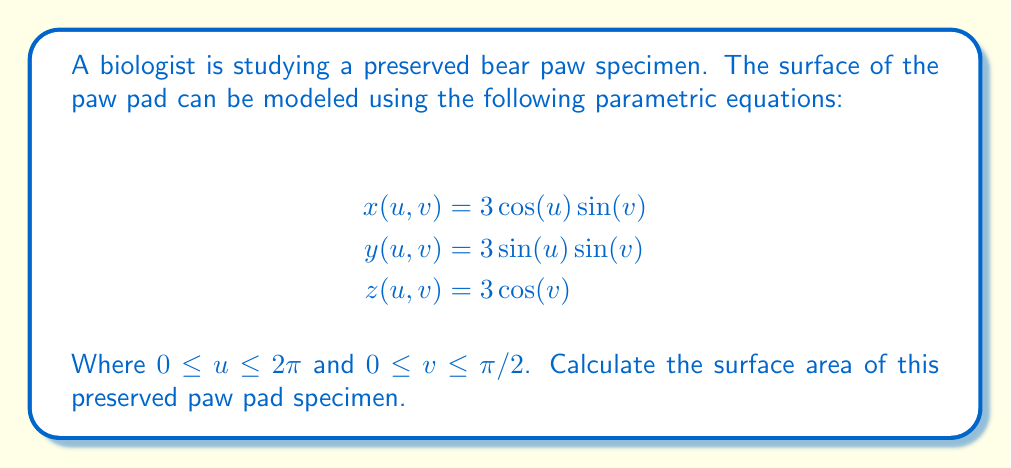Provide a solution to this math problem. To calculate the surface area using parametric equations, we need to use the surface integral formula:

$$\text{Surface Area} = \iint_S \sqrt{EG - F^2} \, du \, dv$$

Where $E$, $F$, and $G$ are coefficients of the first fundamental form:

$$E = \left(\frac{\partial x}{\partial u}\right)^2 + \left(\frac{\partial y}{\partial u}\right)^2 + \left(\frac{\partial z}{\partial u}\right)^2$$
$$F = \frac{\partial x}{\partial u}\frac{\partial x}{\partial v} + \frac{\partial y}{\partial u}\frac{\partial y}{\partial v} + \frac{\partial z}{\partial u}\frac{\partial z}{\partial v}$$
$$G = \left(\frac{\partial x}{\partial v}\right)^2 + \left(\frac{\partial y}{\partial v}\right)^2 + \left(\frac{\partial z}{\partial v}\right)^2$$

Let's calculate these coefficients:

1) First, we need to find the partial derivatives:

   $$\frac{\partial x}{\partial u} = -3\sin(u)\sin(v)$$
   $$\frac{\partial x}{\partial v} = 3\cos(u)\cos(v)$$
   $$\frac{\partial y}{\partial u} = 3\cos(u)\sin(v)$$
   $$\frac{\partial y}{\partial v} = 3\sin(u)\cos(v)$$
   $$\frac{\partial z}{\partial u} = 0$$
   $$\frac{\partial z}{\partial v} = -3\sin(v)$$

2) Now, let's calculate $E$, $F$, and $G$:

   $$E = 9\sin^2(u)\sin^2(v) + 9\cos^2(u)\sin^2(v) + 0 = 9\sin^2(v)$$
   
   $$F = -9\sin(u)\cos(u)\sin(v)\cos(v) + 9\cos(u)\sin(u)\sin(v)\cos(v) + 0 = 0$$
   
   $$G = 9\cos^2(u)\cos^2(v) + 9\sin^2(u)\cos^2(v) + 9\sin^2(v) = 9\cos^2(v) + 9\sin^2(v) = 9$$

3) Now we can calculate $EG - F^2$:

   $$EG - F^2 = 9\sin^2(v) \cdot 9 - 0^2 = 81\sin^2(v)$$

4) Therefore, our surface integral becomes:

   $$\text{Surface Area} = \int_0^{2\pi} \int_0^{\pi/2} \sqrt{81\sin^2(v)} \, dv \, du$$
   $$= \int_0^{2\pi} \int_0^{\pi/2} 9\sin(v) \, dv \, du$$

5) Solving this integral:

   $$= \int_0^{2\pi} \left[-9\cos(v)\right]_0^{\pi/2} \, du$$
   $$= \int_0^{2\pi} 9 \, du$$
   $$= 18\pi$$

Thus, the surface area of the preserved paw pad specimen is $18\pi$ square units.
Answer: $18\pi$ square units 